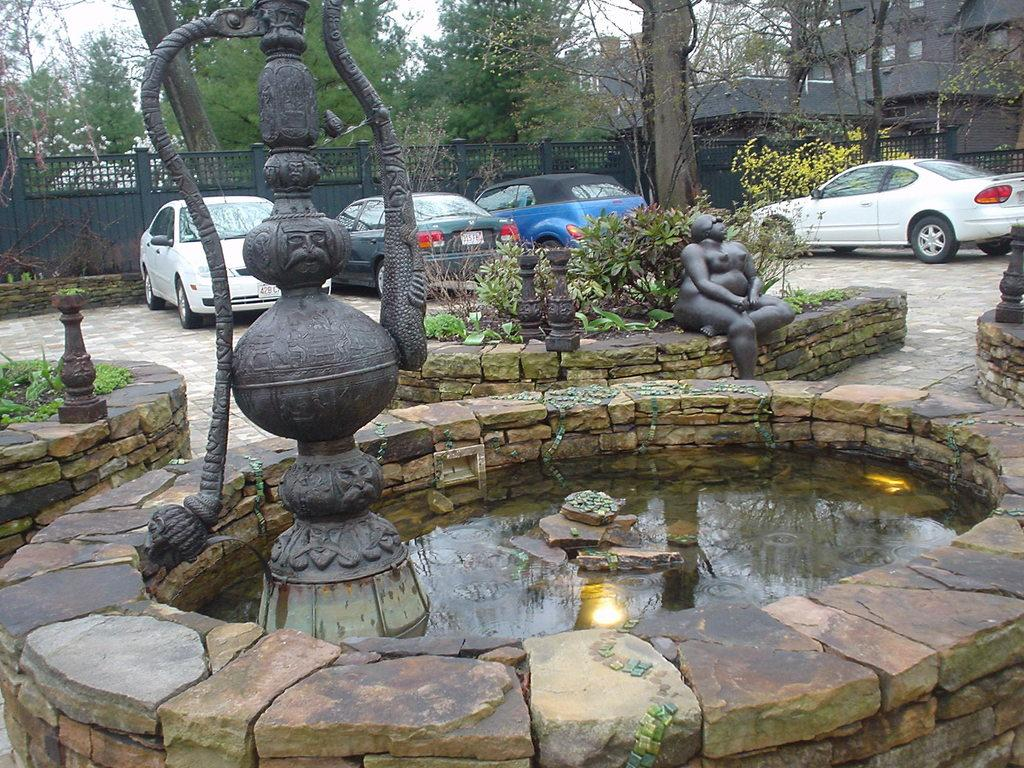What color are the statues in the image? The statues in the image are black in color. What type of natural feature can be seen in the image? There are trees in the image. What is the body of water visible in the image? There is water visible in the image. What type of transportation is present in the image? There are vehicles in the image. What architectural feature can be seen in the image? There is a railing in the image. What type of structure is present in the image? There is a building in the image. What type of windows are present in the building? There are glass windows in the image. What is the color of the sky in the image? The sky appears to be white in color. Can you tell me how many brothers are depicted in the image? There are no people or figures in the image, so it is not possible to determine the presence of any brothers. What type of animals can be seen at the zoo in the image? There is no zoo present in the image; it features black statues, rock walls, trees, water, vehicles, a railing, a building, glass windows, and a white sky. 